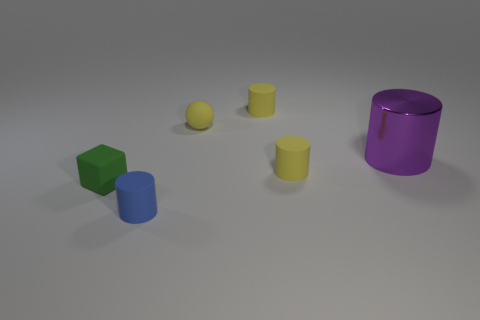Subtract all brown cylinders. Subtract all yellow blocks. How many cylinders are left? 4 Add 3 small blue matte things. How many objects exist? 9 Subtract all balls. How many objects are left? 5 Subtract 1 green cubes. How many objects are left? 5 Subtract all big green metallic cylinders. Subtract all shiny cylinders. How many objects are left? 5 Add 2 large metallic things. How many large metallic things are left? 3 Add 4 small blue rubber things. How many small blue rubber things exist? 5 